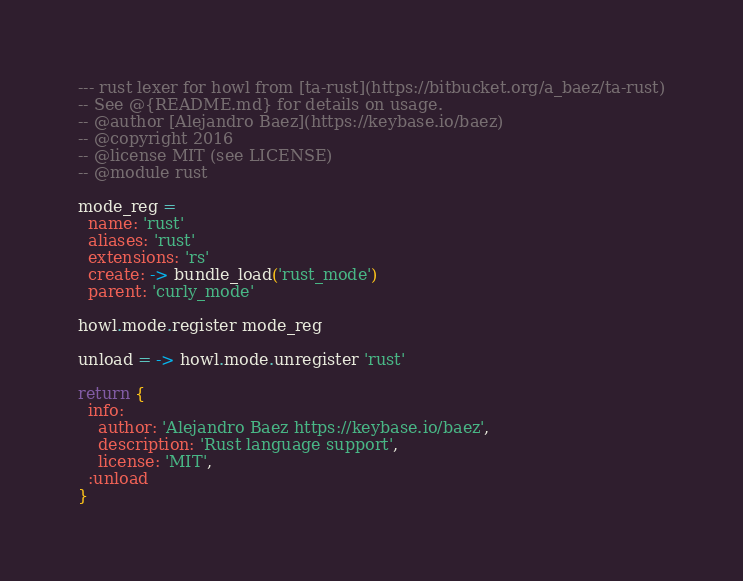Convert code to text. <code><loc_0><loc_0><loc_500><loc_500><_MoonScript_>--- rust lexer for howl from [ta-rust](https://bitbucket.org/a_baez/ta-rust)
-- See @{README.md} for details on usage.
-- @author [Alejandro Baez](https://keybase.io/baez)
-- @copyright 2016
-- @license MIT (see LICENSE)
-- @module rust

mode_reg =
  name: 'rust'
  aliases: 'rust'
  extensions: 'rs'
  create: -> bundle_load('rust_mode')
  parent: 'curly_mode'

howl.mode.register mode_reg

unload = -> howl.mode.unregister 'rust'

return {
  info:
    author: 'Alejandro Baez https://keybase.io/baez',
    description: 'Rust language support',
    license: 'MIT',
  :unload
}
</code> 